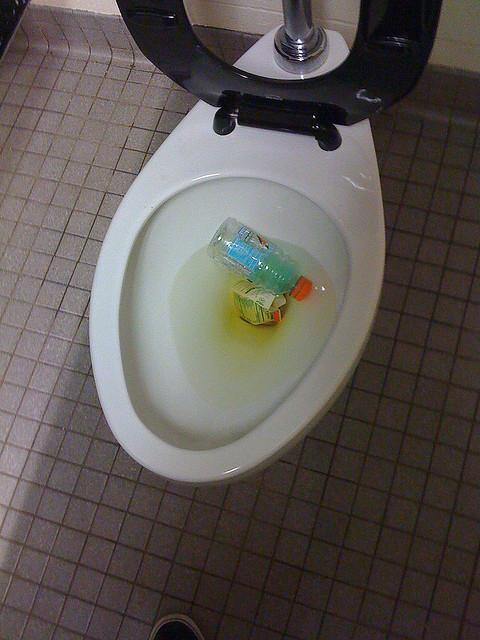Why is that in the toilet bowl?
Answer briefly. Trash. Do those items belong in toilet?
Keep it brief. No. Is the urinal clean?
Be succinct. No. Is the toilet clean?
Give a very brief answer. No. Will someone reach in with their bare hands to clean it?
Keep it brief. No. Is the water in the bowl clean?
Keep it brief. No. Is the pipe on the back of the toilet PVC?
Give a very brief answer. No. Is this toilet clean?
Give a very brief answer. No. Does this toilet look in need of being flushed?
Be succinct. Yes. What is in the toilet bowl?
Be succinct. Trash. Will this toilet flush?
Be succinct. No. What is in the water?
Quick response, please. Bottle. 